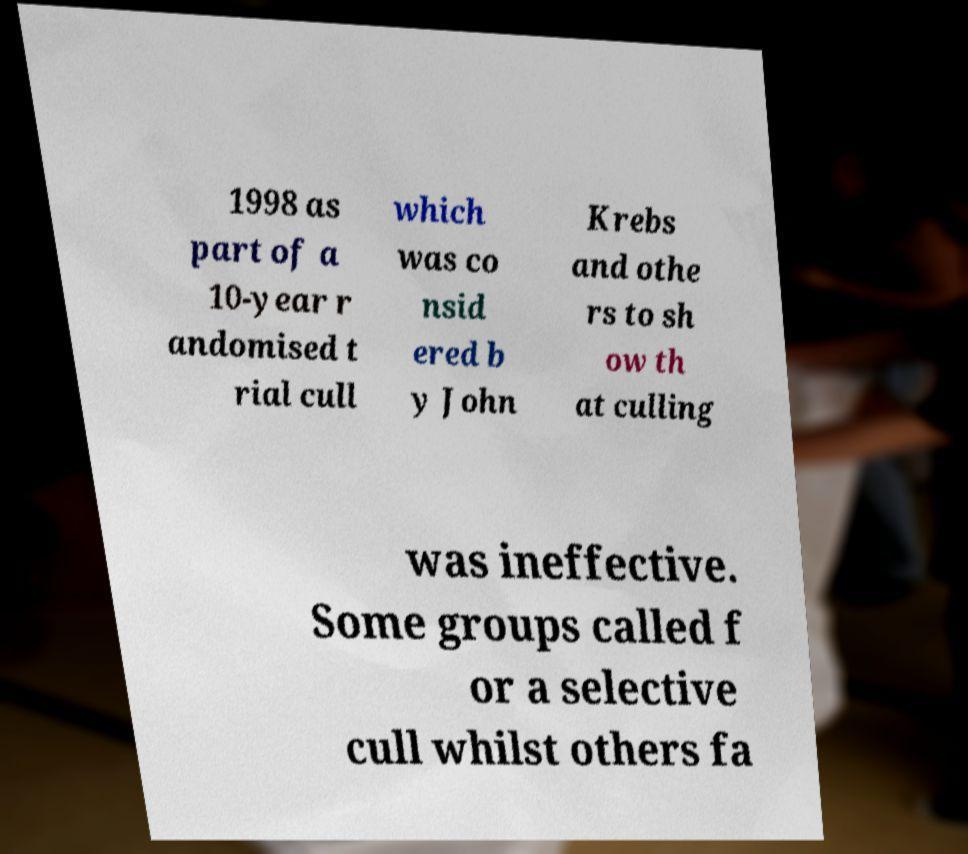I need the written content from this picture converted into text. Can you do that? 1998 as part of a 10-year r andomised t rial cull which was co nsid ered b y John Krebs and othe rs to sh ow th at culling was ineffective. Some groups called f or a selective cull whilst others fa 